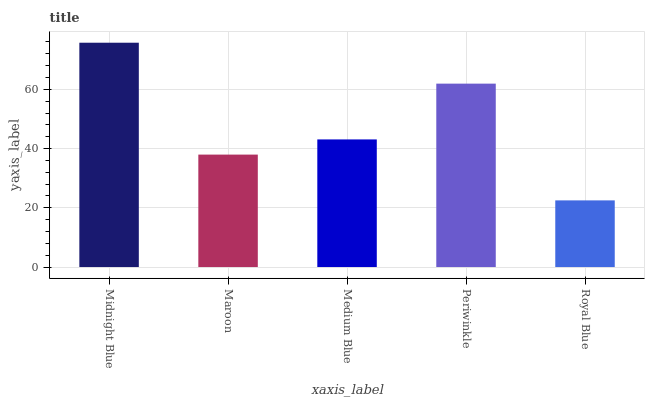Is Royal Blue the minimum?
Answer yes or no. Yes. Is Midnight Blue the maximum?
Answer yes or no. Yes. Is Maroon the minimum?
Answer yes or no. No. Is Maroon the maximum?
Answer yes or no. No. Is Midnight Blue greater than Maroon?
Answer yes or no. Yes. Is Maroon less than Midnight Blue?
Answer yes or no. Yes. Is Maroon greater than Midnight Blue?
Answer yes or no. No. Is Midnight Blue less than Maroon?
Answer yes or no. No. Is Medium Blue the high median?
Answer yes or no. Yes. Is Medium Blue the low median?
Answer yes or no. Yes. Is Maroon the high median?
Answer yes or no. No. Is Maroon the low median?
Answer yes or no. No. 